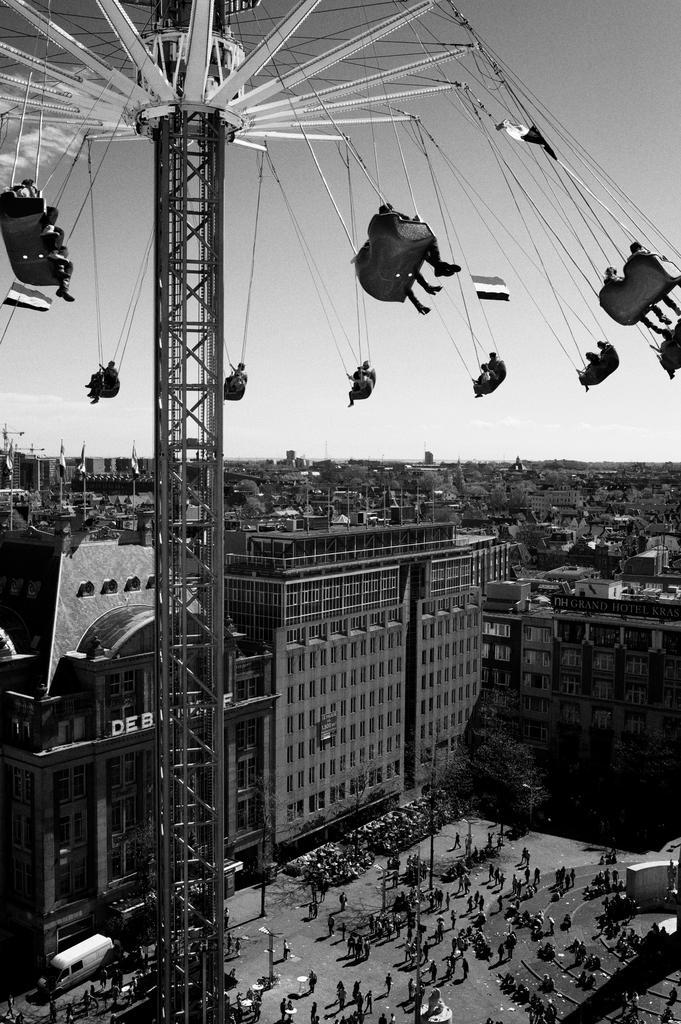In one or two sentences, can you explain what this image depicts? This is a black and white image, in this image in the foreground there is one tower and in the background there are some buildings and houses. At the bottom there are some people who are standing, and also there are some vehicles. At the top of the image there is sky. 